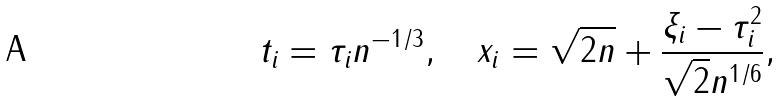<formula> <loc_0><loc_0><loc_500><loc_500>t _ { i } = \tau _ { i } n ^ { - 1 / 3 } , \quad x _ { i } = \sqrt { 2 n } + \frac { \xi _ { i } - \tau _ { i } ^ { 2 } } { \sqrt { 2 } n ^ { 1 / 6 } } ,</formula> 